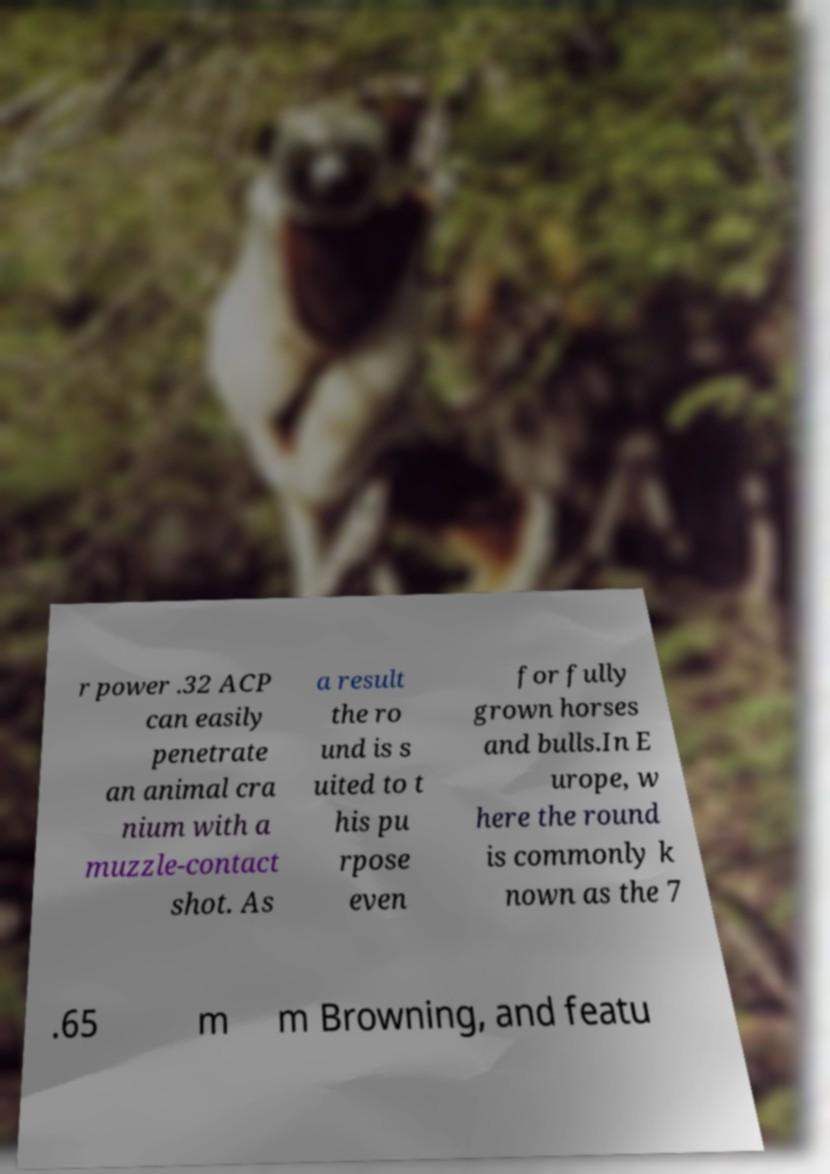Can you read and provide the text displayed in the image?This photo seems to have some interesting text. Can you extract and type it out for me? r power .32 ACP can easily penetrate an animal cra nium with a muzzle-contact shot. As a result the ro und is s uited to t his pu rpose even for fully grown horses and bulls.In E urope, w here the round is commonly k nown as the 7 .65 m m Browning, and featu 